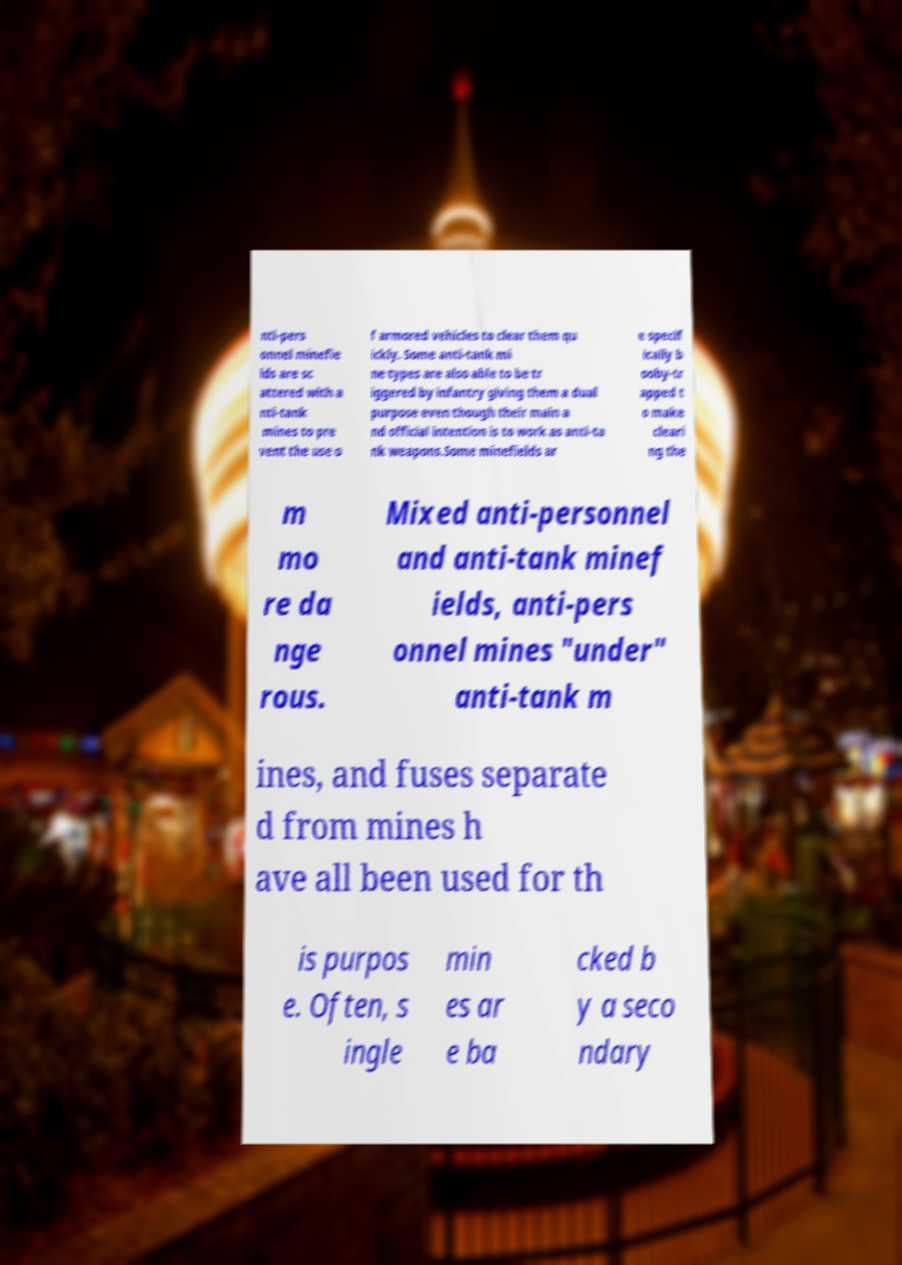Could you assist in decoding the text presented in this image and type it out clearly? nti-pers onnel minefie lds are sc attered with a nti-tank mines to pre vent the use o f armored vehicles to clear them qu ickly. Some anti-tank mi ne types are also able to be tr iggered by infantry giving them a dual purpose even though their main a nd official intention is to work as anti-ta nk weapons.Some minefields ar e specif ically b ooby-tr apped t o make cleari ng the m mo re da nge rous. Mixed anti-personnel and anti-tank minef ields, anti-pers onnel mines "under" anti-tank m ines, and fuses separate d from mines h ave all been used for th is purpos e. Often, s ingle min es ar e ba cked b y a seco ndary 